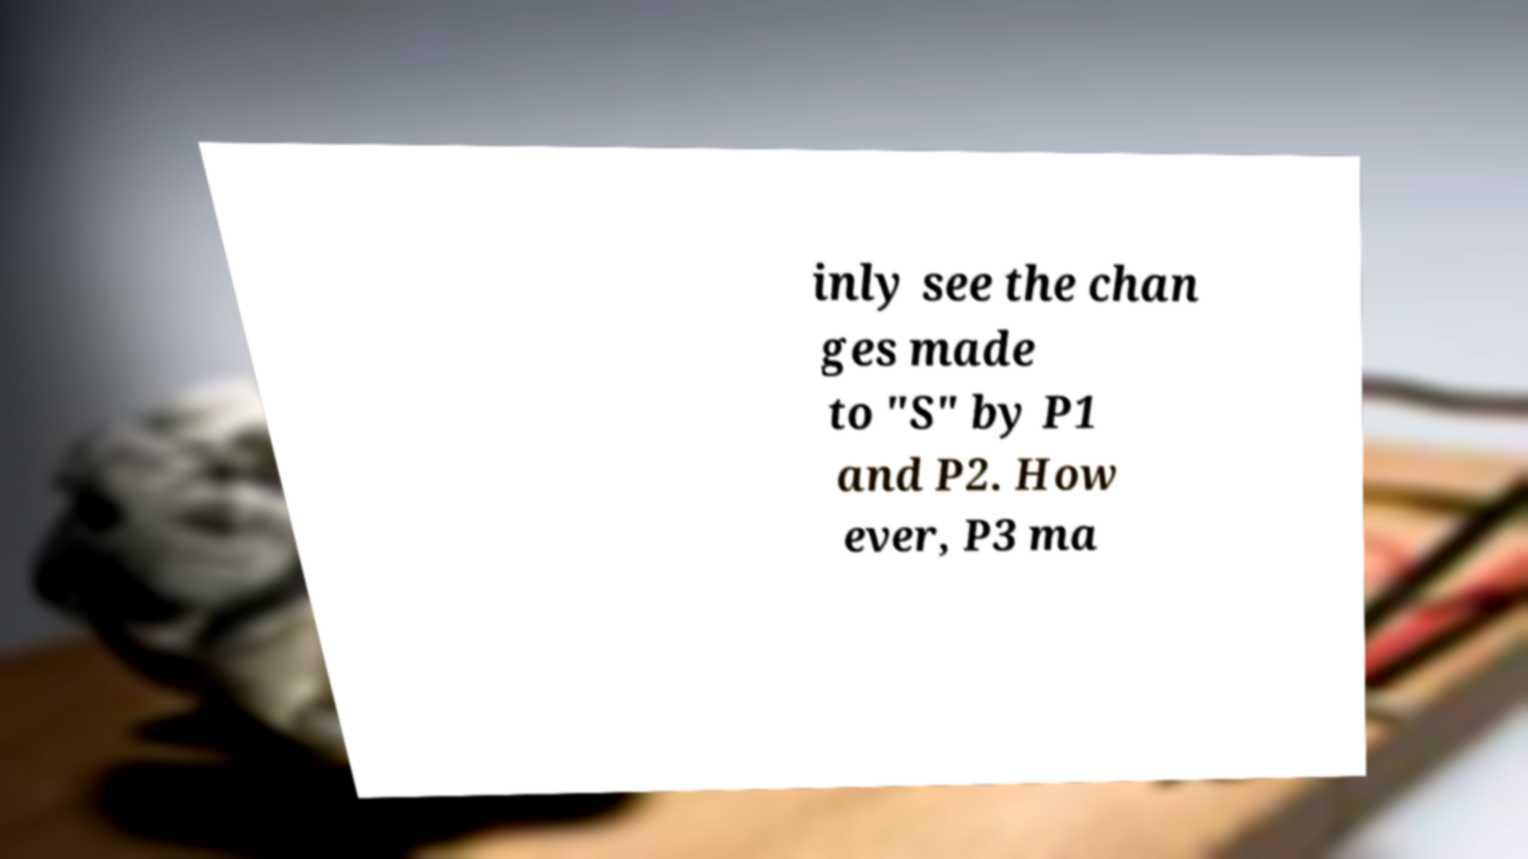What messages or text are displayed in this image? I need them in a readable, typed format. inly see the chan ges made to "S" by P1 and P2. How ever, P3 ma 